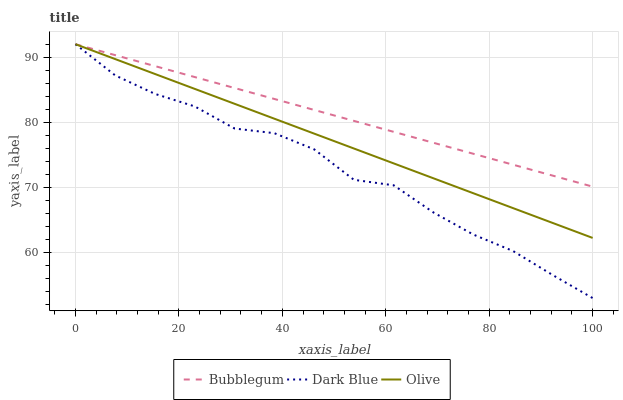Does Dark Blue have the minimum area under the curve?
Answer yes or no. Yes. Does Bubblegum have the maximum area under the curve?
Answer yes or no. Yes. Does Bubblegum have the minimum area under the curve?
Answer yes or no. No. Does Dark Blue have the maximum area under the curve?
Answer yes or no. No. Is Olive the smoothest?
Answer yes or no. Yes. Is Dark Blue the roughest?
Answer yes or no. Yes. Is Bubblegum the smoothest?
Answer yes or no. No. Is Bubblegum the roughest?
Answer yes or no. No. Does Dark Blue have the lowest value?
Answer yes or no. Yes. Does Bubblegum have the lowest value?
Answer yes or no. No. Does Bubblegum have the highest value?
Answer yes or no. Yes. Does Dark Blue intersect Bubblegum?
Answer yes or no. Yes. Is Dark Blue less than Bubblegum?
Answer yes or no. No. Is Dark Blue greater than Bubblegum?
Answer yes or no. No. 